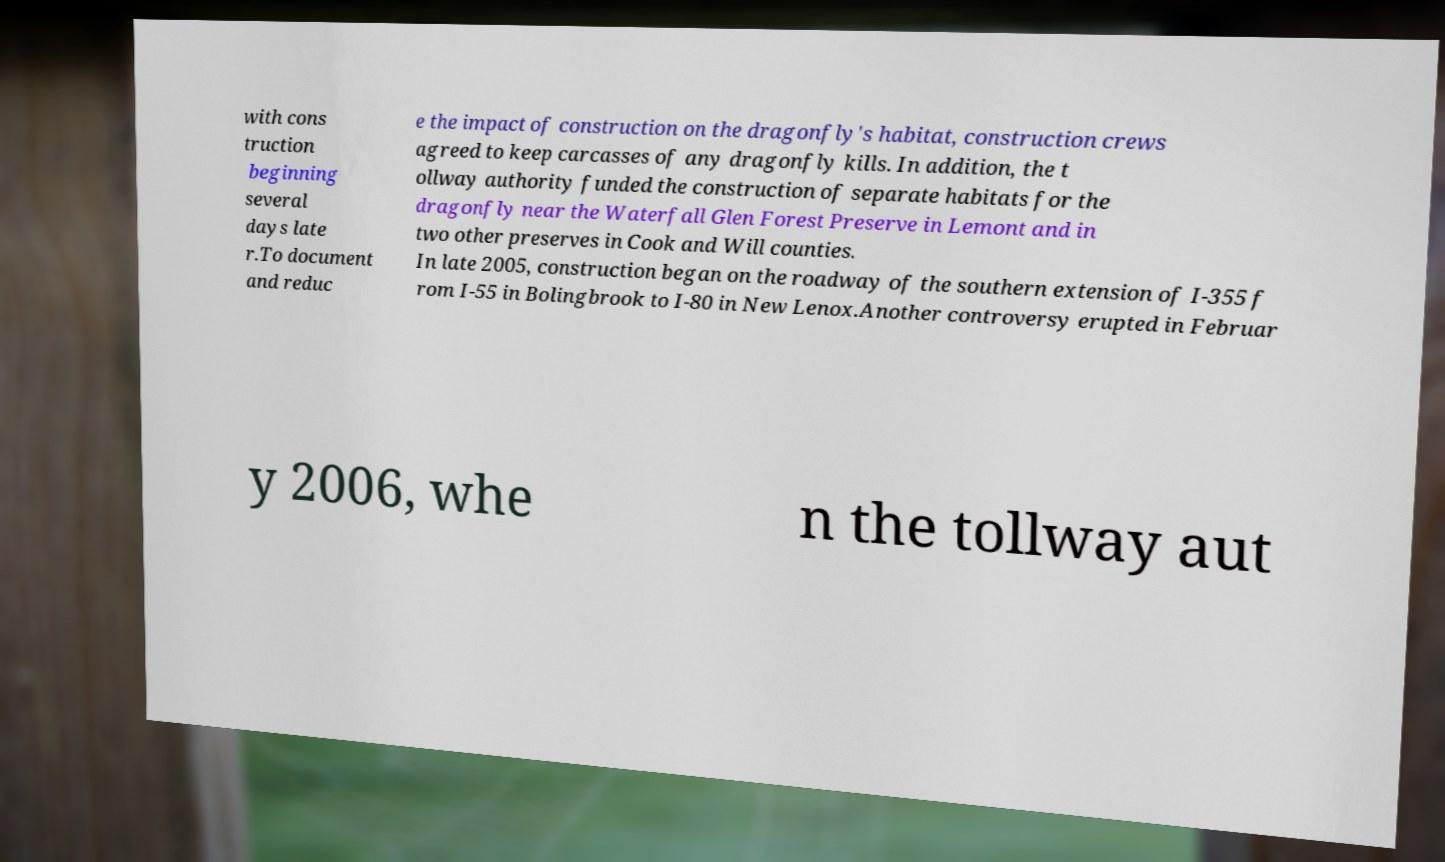Could you assist in decoding the text presented in this image and type it out clearly? with cons truction beginning several days late r.To document and reduc e the impact of construction on the dragonfly's habitat, construction crews agreed to keep carcasses of any dragonfly kills. In addition, the t ollway authority funded the construction of separate habitats for the dragonfly near the Waterfall Glen Forest Preserve in Lemont and in two other preserves in Cook and Will counties. In late 2005, construction began on the roadway of the southern extension of I-355 f rom I-55 in Bolingbrook to I-80 in New Lenox.Another controversy erupted in Februar y 2006, whe n the tollway aut 